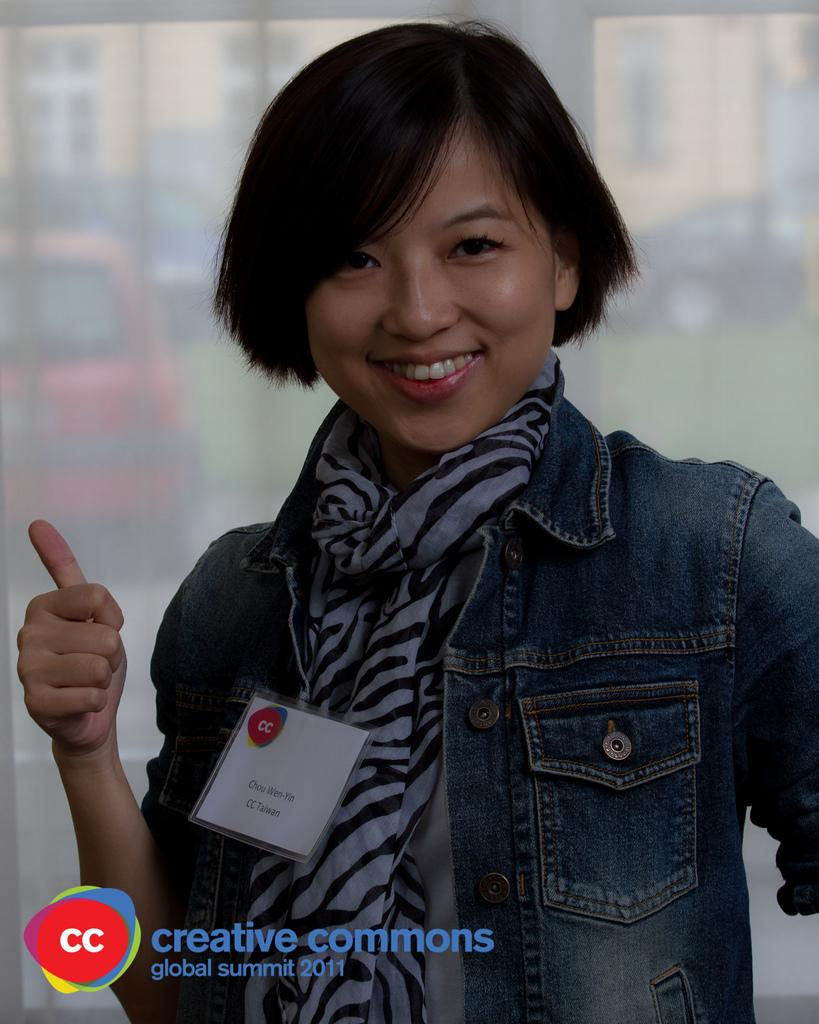Who is present in the image? There is a person in the image. What is the person's facial expression? The person is smiling. What type of architectural feature can be seen in the image? There is a glass window in the image. What can be seen in the distance in the image? There are buildings and cars in the background of the image. What type of pets are visible in the image? There are no pets visible in the image. What topics are being discussed by the person in the image? The image does not provide any information about a discussion or the topics being discussed. 